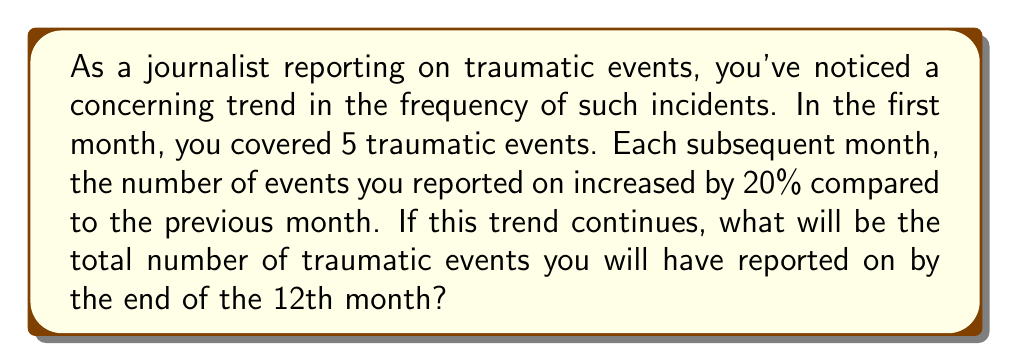What is the answer to this math problem? Let's approach this problem using a geometric series:

1) First, we need to identify our initial term and common ratio:
   - Initial term (a): 5 events in the first month
   - Common ratio (r): 1.20 (20% increase = 1 + 0.20 = 1.20)

2) The number of events for each month forms a geometric sequence:
   Month 1: $5$
   Month 2: $5 \cdot 1.20 = 6$
   Month 3: $5 \cdot 1.20^2 = 7.2$
   ...and so on.

3) We want to find the sum of this sequence for 12 terms. The formula for the sum of a geometric series is:

   $S_n = \frac{a(1-r^n)}{1-r}$, where $a$ is the first term, $r$ is the common ratio, and $n$ is the number of terms.

4) Plugging in our values:
   $S_{12} = \frac{5(1-1.20^{12})}{1-1.20}$

5) Calculating:
   $S_{12} = \frac{5(1-8.916)}{-0.20} = \frac{5(-7.916)}{-0.20} = 197.9$

6) Since we're dealing with whole events, we round to the nearest integer: 198.

Therefore, by the end of the 12th month, you will have reported on a total of 198 traumatic events.
Answer: 198 traumatic events 